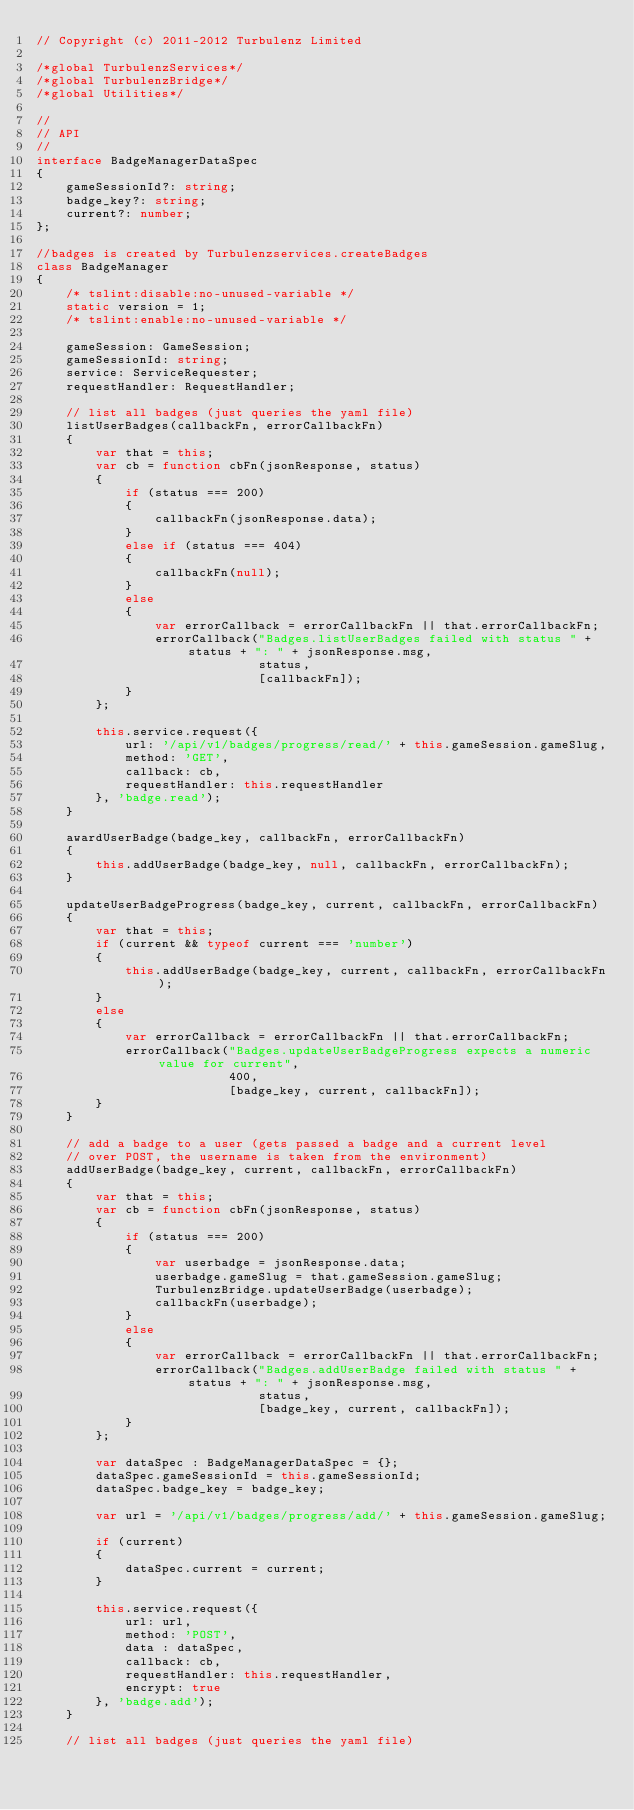<code> <loc_0><loc_0><loc_500><loc_500><_TypeScript_>// Copyright (c) 2011-2012 Turbulenz Limited

/*global TurbulenzServices*/
/*global TurbulenzBridge*/
/*global Utilities*/

//
// API
//
interface BadgeManagerDataSpec
{
    gameSessionId?: string;
    badge_key?: string;
    current?: number;
};

//badges is created by Turbulenzservices.createBadges
class BadgeManager
{
    /* tslint:disable:no-unused-variable */
    static version = 1;
    /* tslint:enable:no-unused-variable */

    gameSession: GameSession;
    gameSessionId: string;
    service: ServiceRequester;
    requestHandler: RequestHandler;

    // list all badges (just queries the yaml file)
    listUserBadges(callbackFn, errorCallbackFn)
    {
        var that = this;
        var cb = function cbFn(jsonResponse, status)
        {
            if (status === 200)
            {
                callbackFn(jsonResponse.data);
            }
            else if (status === 404)
            {
                callbackFn(null);
            }
            else
            {
                var errorCallback = errorCallbackFn || that.errorCallbackFn;
                errorCallback("Badges.listUserBadges failed with status " + status + ": " + jsonResponse.msg,
                              status,
                              [callbackFn]);
            }
        };

        this.service.request({
            url: '/api/v1/badges/progress/read/' + this.gameSession.gameSlug,
            method: 'GET',
            callback: cb,
            requestHandler: this.requestHandler
        }, 'badge.read');
    }

    awardUserBadge(badge_key, callbackFn, errorCallbackFn)
    {
        this.addUserBadge(badge_key, null, callbackFn, errorCallbackFn);
    }

    updateUserBadgeProgress(badge_key, current, callbackFn, errorCallbackFn)
    {
        var that = this;
        if (current && typeof current === 'number')
        {
            this.addUserBadge(badge_key, current, callbackFn, errorCallbackFn);
        }
        else
        {
            var errorCallback = errorCallbackFn || that.errorCallbackFn;
            errorCallback("Badges.updateUserBadgeProgress expects a numeric value for current",
                          400,
                          [badge_key, current, callbackFn]);
        }
    }

    // add a badge to a user (gets passed a badge and a current level
    // over POST, the username is taken from the environment)
    addUserBadge(badge_key, current, callbackFn, errorCallbackFn)
    {
        var that = this;
        var cb = function cbFn(jsonResponse, status)
        {
            if (status === 200)
            {
                var userbadge = jsonResponse.data;
                userbadge.gameSlug = that.gameSession.gameSlug;
                TurbulenzBridge.updateUserBadge(userbadge);
                callbackFn(userbadge);
            }
            else
            {
                var errorCallback = errorCallbackFn || that.errorCallbackFn;
                errorCallback("Badges.addUserBadge failed with status " + status + ": " + jsonResponse.msg,
                              status,
                              [badge_key, current, callbackFn]);
            }
        };

        var dataSpec : BadgeManagerDataSpec = {};
        dataSpec.gameSessionId = this.gameSessionId;
        dataSpec.badge_key = badge_key;

        var url = '/api/v1/badges/progress/add/' + this.gameSession.gameSlug;

        if (current)
        {
            dataSpec.current = current;
        }

        this.service.request({
            url: url,
            method: 'POST',
            data : dataSpec,
            callback: cb,
            requestHandler: this.requestHandler,
            encrypt: true
        }, 'badge.add');
    }

    // list all badges (just queries the yaml file)</code> 